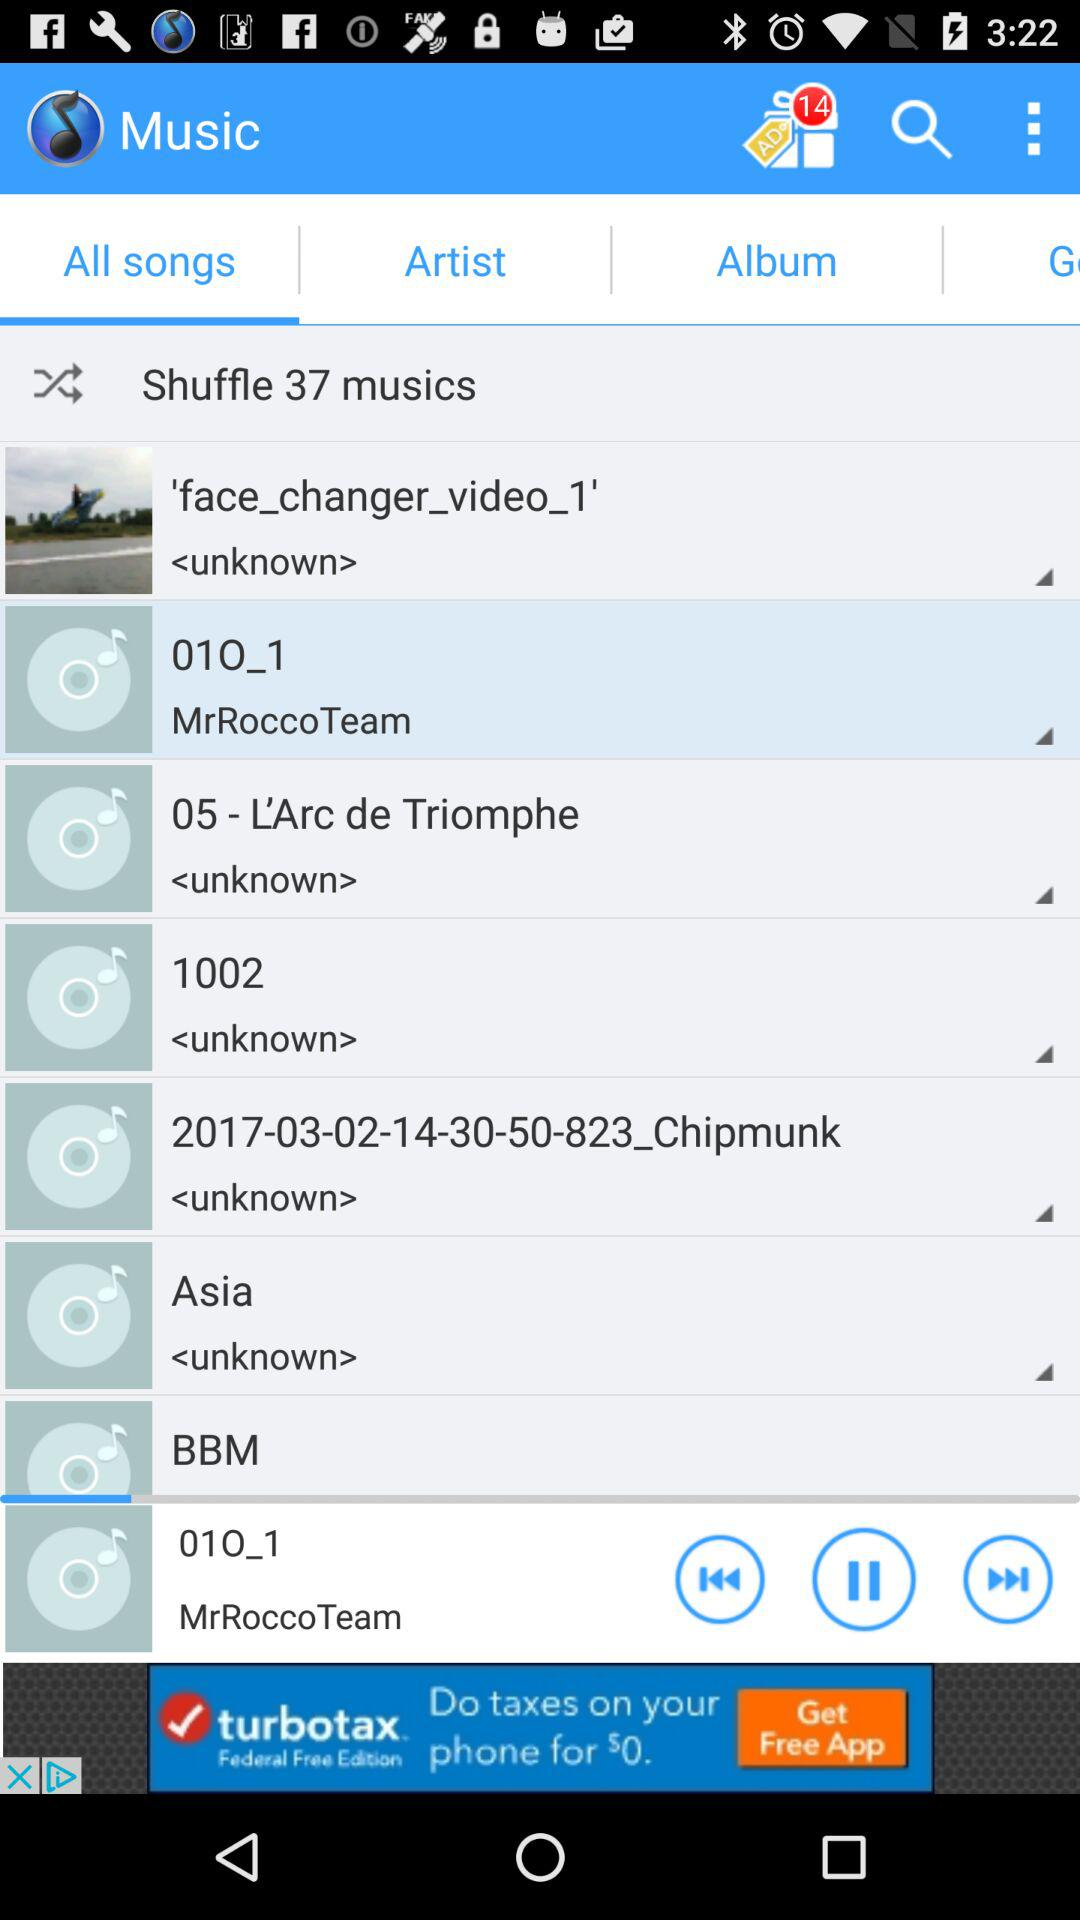Which tab is currently selected? The currently selected tab is "All songs". 